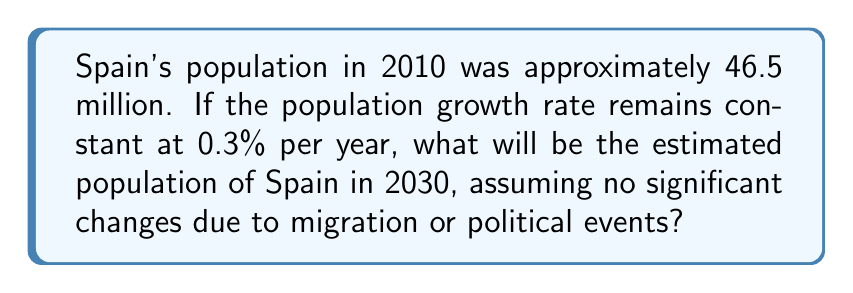Solve this math problem. To solve this problem, we'll use the exponential growth model:

$$ P(t) = P_0 \cdot e^{rt} $$

Where:
$P(t)$ is the population at time $t$
$P_0$ is the initial population
$r$ is the growth rate (as a decimal)
$t$ is the time in years

Given:
$P_0 = 46.5$ million (in 2010)
$r = 0.003$ (0.3% expressed as a decimal)
$t = 20$ years (from 2010 to 2030)

Let's substitute these values into the formula:

$$ P(20) = 46.5 \cdot e^{0.003 \cdot 20} $$

Now we can calculate:

$$ P(20) = 46.5 \cdot e^{0.06} $$
$$ P(20) = 46.5 \cdot 1.0618 $$
$$ P(20) = 49.37 $$

Therefore, the estimated population of Spain in 2030 will be approximately 49.37 million.
Answer: 49.37 million 